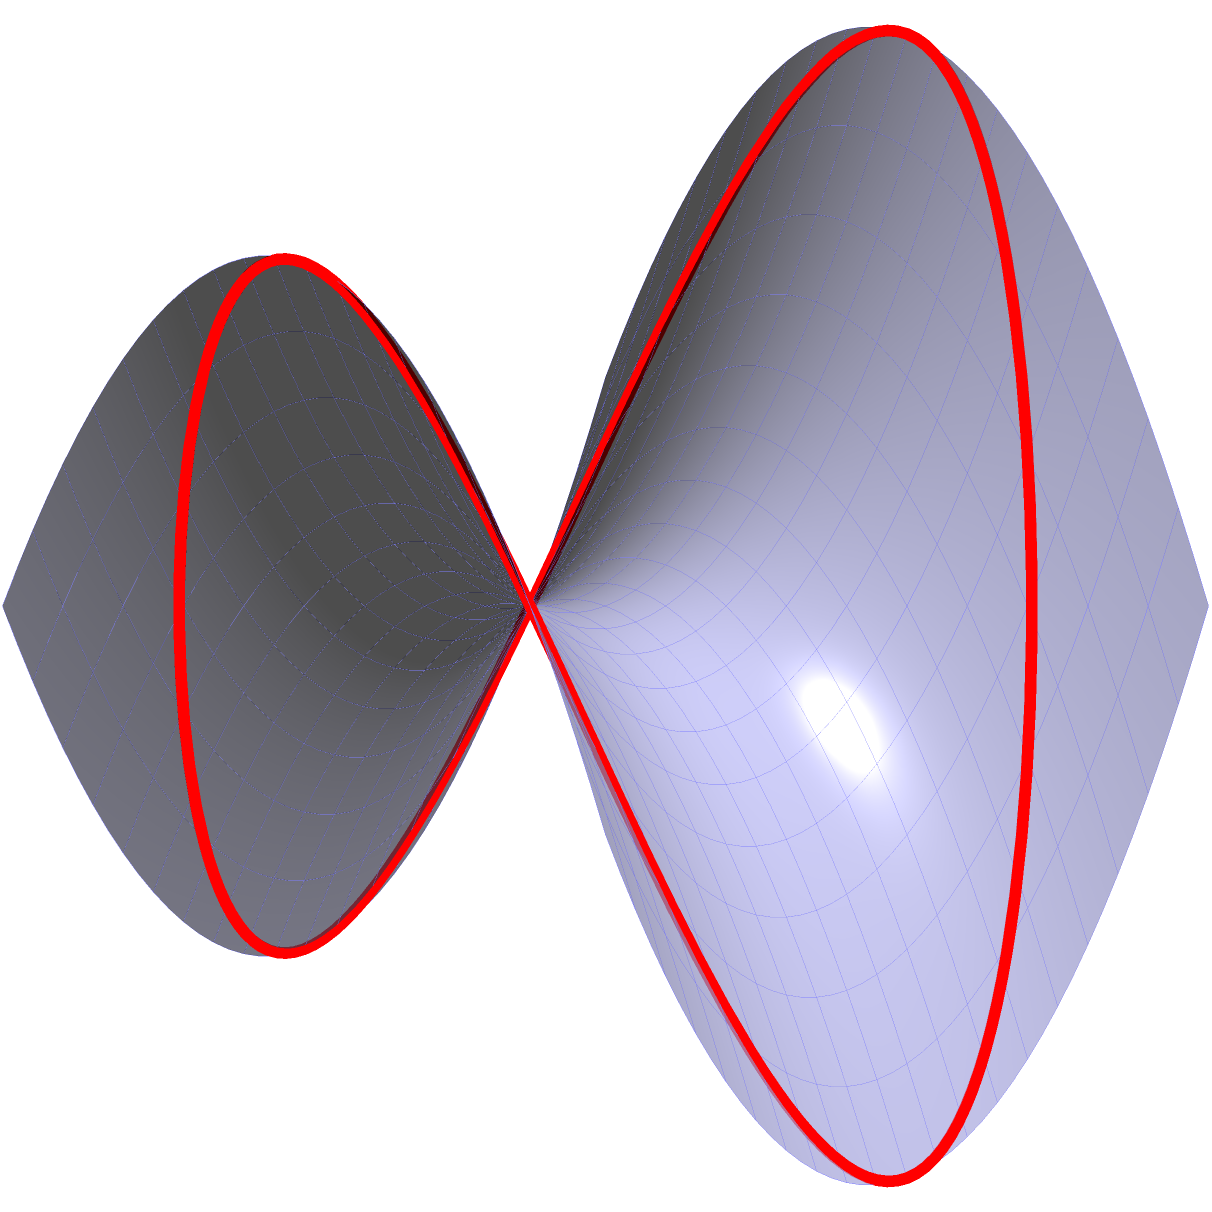In the context of Non-Euclidean Geometry, consider a saddle-shaped surface defined by the function $z = x^2 - y^2$. A geodesic curve is drawn on this surface as shown in red. How does the behavior of this geodesic differ from a straight line on a flat plane, and what implications might this have for the efficiency of autonomous robots navigating on complex surfaces? To understand the behavior of the geodesic on the saddle-shaped surface:

1. Surface properties:
   The surface is defined by $z = x^2 - y^2$, which creates a saddle shape with negative curvature.

2. Geodesic behavior:
   a) Unlike straight lines on a flat plane, geodesics on this surface follow curved paths.
   b) The geodesic shown is roughly circular when projected onto the xy-plane.
   c) It undulates up and down as it traverses the surface.

3. Differences from flat plane:
   a) Path length: Geodesics on this surface are longer than straight lines connecting the same points in a flat plane.
   b) Curvature: The path curves both in the xy-plane and in the z-direction.
   c) Parallel lines: Two initially parallel geodesics may diverge or converge, unlike on a flat plane.

4. Implications for autonomous robots:
   a) Path planning: Robots must account for the surface curvature when calculating optimal paths.
   b) Energy efficiency: More energy may be required to traverse curved paths compared to flat surfaces.
   c) Sensors and control: Robots need sophisticated sensors and control systems to navigate the changing surface slopes.
   d) Localization: Traditional flat-plane mapping techniques may not be sufficient for accurate positioning.

5. Productivity considerations:
   a) Increased complexity in navigation algorithms may lead to longer computation times.
   b) Specialized hardware might be needed, potentially increasing costs.
   c) The efficiency of tasks performed on such surfaces may decrease compared to flat environments.

Understanding these geodesic properties is crucial for optimizing automated systems in non-flat environments, directly impacting labor productivity in complex terrain applications.
Answer: Geodesics curve in 3D, unlike straight lines on flat planes, requiring more complex navigation algorithms and potentially reducing efficiency for autonomous robots on non-flat surfaces. 